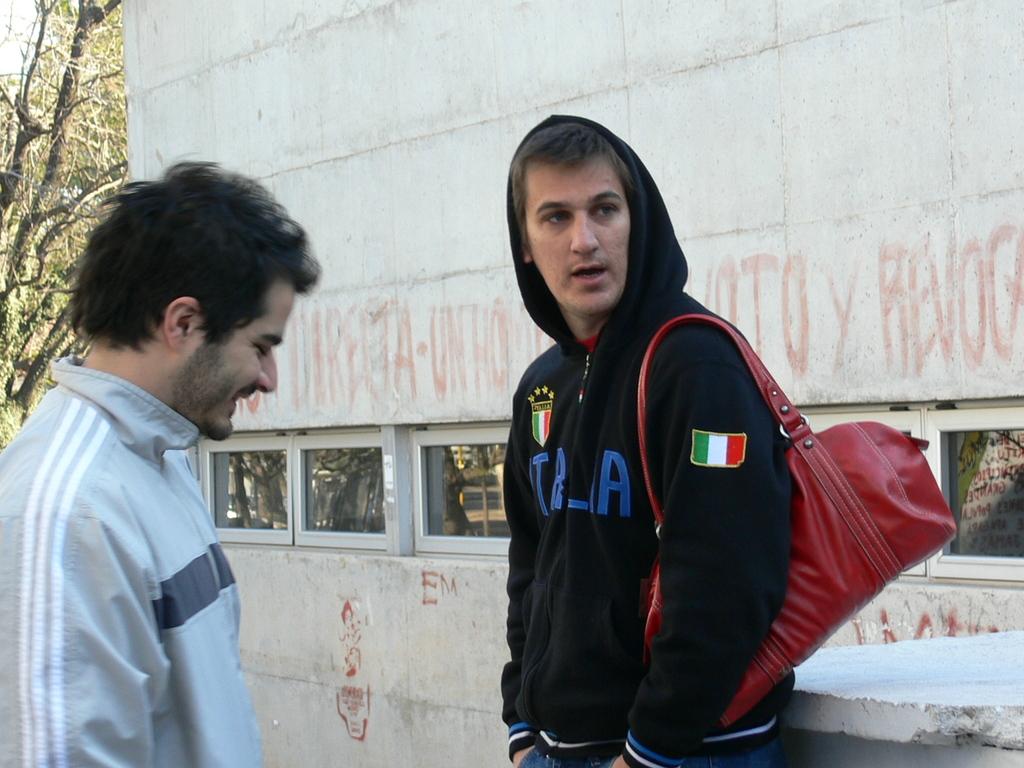What's in blue letters on the front of the black hoody of the man on the right?
Give a very brief answer. Italia. What word is on the building behind him?
Offer a very short reply. Unanswerable. 